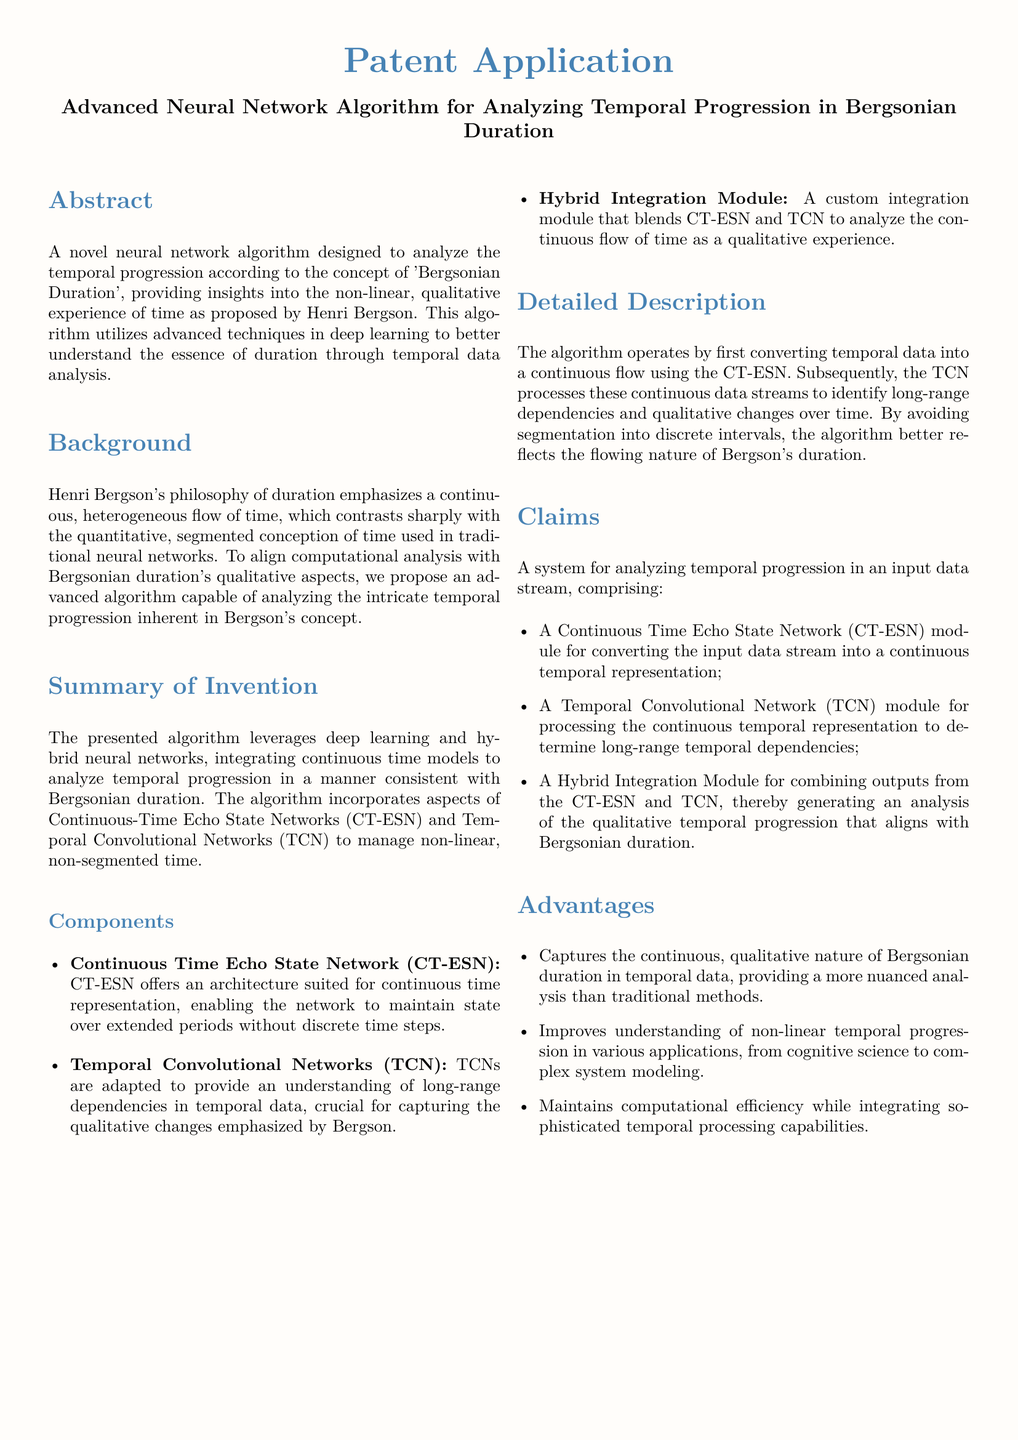What is the title of the patent application? The title of the patent application is stated in the document's header.
Answer: Advanced Neural Network Algorithm for Analyzing Temporal Progression in Bergsonian Duration What concept does the algorithm analyze? The document specifies the philosophical concept that the algorithm is designed to analyze.
Answer: Bergsonian Duration What type of network is used for continuous time representation? The document identifies a specific module used in the algorithm that represents continuous time.
Answer: Continuous Time Echo State Network (CT-ESN) What type of analysis does the algorithm provide? The document highlights the type of analysis that aligns with the philosophical perspective it is based on.
Answer: Qualitative analysis What is the main advantage of the proposed algorithm? The document lists an advantage concerning its ability to capture specific aspects of time.
Answer: Captures the continuous, qualitative nature of Bergsonian duration in temporal data What modules are combined in the hybrid integration? The document mentions two specific modules that are integrated in a custom module.
Answer: CT-ESN and TCN What does TCN stand for? The abbreviation for the type of network used for processing in the algorithm is defined in the document.
Answer: Temporal Convolutional Network How does the algorithm reflect Bergson's duration? The document explains how the algorithm models temporal progression without discrete intervals.
Answer: By avoiding segmentation into discrete intervals 